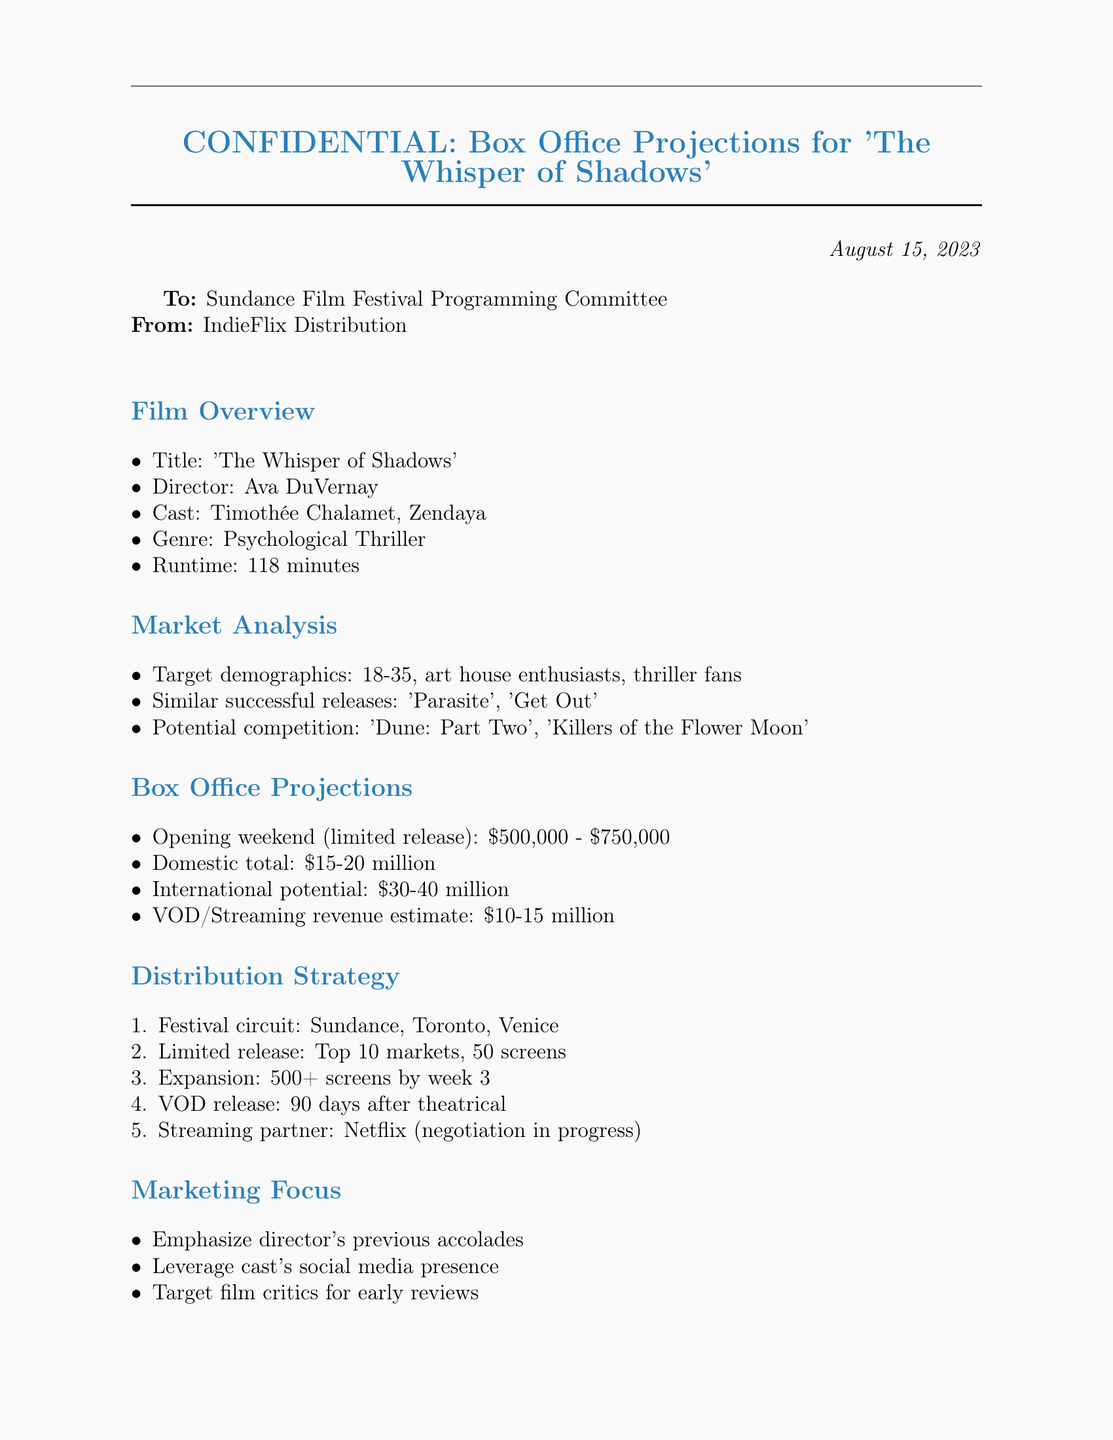What is the title of the film? The title of the film is stated in the document's Film Overview section.
Answer: 'The Whisper of Shadows' Who is the director of 'The Whisper of Shadows'? The director's name is provided in the Film Overview section of the document.
Answer: Ava DuVernay What is the estimated opening weekend revenue for the film? The opening weekend revenue is found in the Box Office Projections section.
Answer: $500,000 - $750,000 What is the target demographic for the film? The target demographic is listed in the Market Analysis section.
Answer: 18-35 Which streaming partner is mentioned in the distribution strategy? The streaming partner is noted in the Distribution Strategy section of the document.
Answer: Netflix What is the estimated domestic total revenue for 'The Whisper of Shadows'? The domestic total revenue is provided in the Box Office Projections section.
Answer: $15-20 million In which festival circuit is 'The Whisper of Shadows' planning to participate? The participating festival circuit is detailed in the Distribution Strategy section.
Answer: Sundance, Toronto, Venice How many screens will the film release on during its limited release? The number of screens for the limited release is mentioned in the Distribution Strategy section.
Answer: 50 screens What is the potential international revenue for the film? The potential international revenue is outlined in the Box Office Projections section.
Answer: $30-40 million 